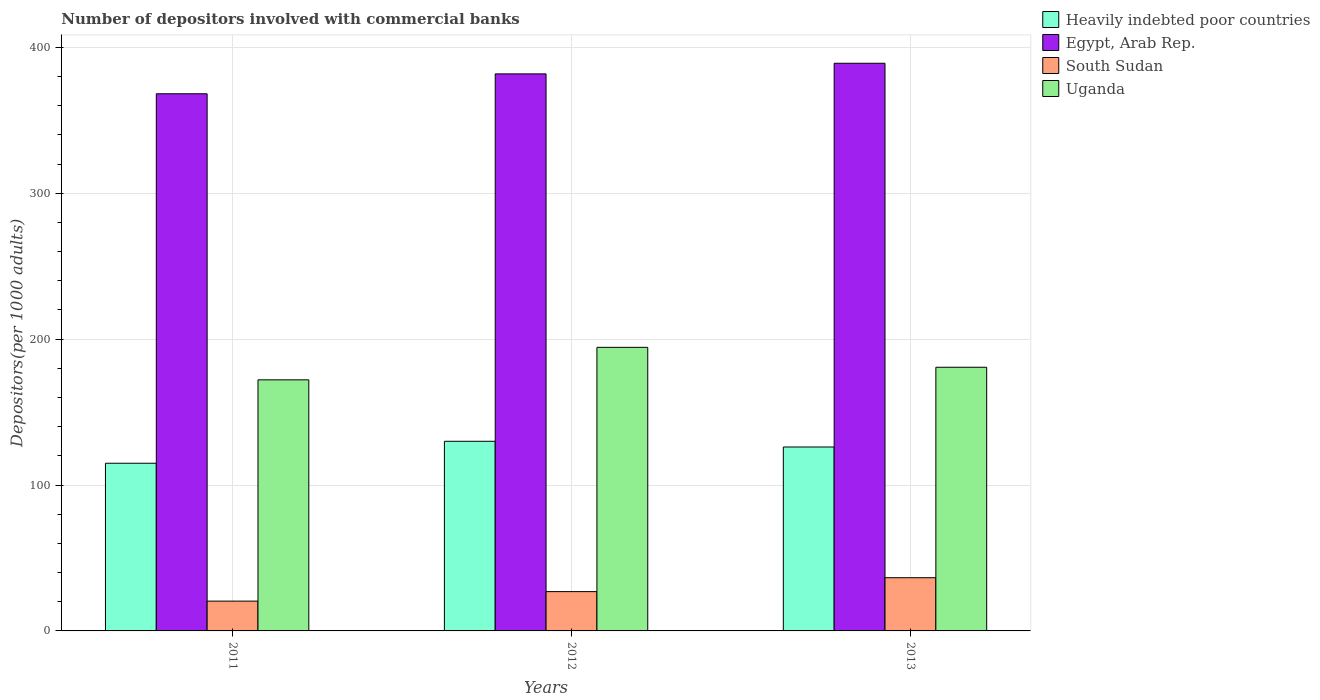How many different coloured bars are there?
Give a very brief answer. 4. Are the number of bars on each tick of the X-axis equal?
Ensure brevity in your answer.  Yes. What is the number of depositors involved with commercial banks in South Sudan in 2011?
Ensure brevity in your answer.  20.42. Across all years, what is the maximum number of depositors involved with commercial banks in Egypt, Arab Rep.?
Your answer should be compact. 389.11. Across all years, what is the minimum number of depositors involved with commercial banks in Heavily indebted poor countries?
Ensure brevity in your answer.  114.93. In which year was the number of depositors involved with commercial banks in Heavily indebted poor countries maximum?
Offer a very short reply. 2012. What is the total number of depositors involved with commercial banks in South Sudan in the graph?
Offer a very short reply. 83.84. What is the difference between the number of depositors involved with commercial banks in South Sudan in 2011 and that in 2013?
Offer a terse response. -16.05. What is the difference between the number of depositors involved with commercial banks in Heavily indebted poor countries in 2011 and the number of depositors involved with commercial banks in South Sudan in 2013?
Provide a short and direct response. 78.46. What is the average number of depositors involved with commercial banks in Egypt, Arab Rep. per year?
Make the answer very short. 379.71. In the year 2011, what is the difference between the number of depositors involved with commercial banks in Egypt, Arab Rep. and number of depositors involved with commercial banks in South Sudan?
Offer a terse response. 347.77. What is the ratio of the number of depositors involved with commercial banks in South Sudan in 2012 to that in 2013?
Offer a terse response. 0.74. Is the number of depositors involved with commercial banks in Heavily indebted poor countries in 2011 less than that in 2013?
Make the answer very short. Yes. Is the difference between the number of depositors involved with commercial banks in Egypt, Arab Rep. in 2011 and 2012 greater than the difference between the number of depositors involved with commercial banks in South Sudan in 2011 and 2012?
Make the answer very short. No. What is the difference between the highest and the second highest number of depositors involved with commercial banks in Heavily indebted poor countries?
Offer a terse response. 3.91. What is the difference between the highest and the lowest number of depositors involved with commercial banks in Egypt, Arab Rep.?
Your response must be concise. 20.91. In how many years, is the number of depositors involved with commercial banks in Egypt, Arab Rep. greater than the average number of depositors involved with commercial banks in Egypt, Arab Rep. taken over all years?
Provide a succinct answer. 2. Is the sum of the number of depositors involved with commercial banks in South Sudan in 2012 and 2013 greater than the maximum number of depositors involved with commercial banks in Heavily indebted poor countries across all years?
Ensure brevity in your answer.  No. Is it the case that in every year, the sum of the number of depositors involved with commercial banks in Egypt, Arab Rep. and number of depositors involved with commercial banks in South Sudan is greater than the sum of number of depositors involved with commercial banks in Uganda and number of depositors involved with commercial banks in Heavily indebted poor countries?
Your answer should be compact. Yes. What does the 4th bar from the left in 2011 represents?
Ensure brevity in your answer.  Uganda. What does the 4th bar from the right in 2013 represents?
Your response must be concise. Heavily indebted poor countries. Is it the case that in every year, the sum of the number of depositors involved with commercial banks in Uganda and number of depositors involved with commercial banks in Egypt, Arab Rep. is greater than the number of depositors involved with commercial banks in South Sudan?
Your response must be concise. Yes. How many bars are there?
Keep it short and to the point. 12. How many years are there in the graph?
Your response must be concise. 3. What is the difference between two consecutive major ticks on the Y-axis?
Provide a short and direct response. 100. Does the graph contain any zero values?
Keep it short and to the point. No. What is the title of the graph?
Ensure brevity in your answer.  Number of depositors involved with commercial banks. Does "Denmark" appear as one of the legend labels in the graph?
Offer a terse response. No. What is the label or title of the Y-axis?
Keep it short and to the point. Depositors(per 1000 adults). What is the Depositors(per 1000 adults) of Heavily indebted poor countries in 2011?
Ensure brevity in your answer.  114.93. What is the Depositors(per 1000 adults) in Egypt, Arab Rep. in 2011?
Your answer should be compact. 368.19. What is the Depositors(per 1000 adults) in South Sudan in 2011?
Make the answer very short. 20.42. What is the Depositors(per 1000 adults) in Uganda in 2011?
Keep it short and to the point. 172.11. What is the Depositors(per 1000 adults) of Heavily indebted poor countries in 2012?
Make the answer very short. 129.98. What is the Depositors(per 1000 adults) in Egypt, Arab Rep. in 2012?
Ensure brevity in your answer.  381.83. What is the Depositors(per 1000 adults) in South Sudan in 2012?
Make the answer very short. 26.94. What is the Depositors(per 1000 adults) in Uganda in 2012?
Give a very brief answer. 194.39. What is the Depositors(per 1000 adults) in Heavily indebted poor countries in 2013?
Your answer should be compact. 126.07. What is the Depositors(per 1000 adults) in Egypt, Arab Rep. in 2013?
Provide a short and direct response. 389.11. What is the Depositors(per 1000 adults) in South Sudan in 2013?
Give a very brief answer. 36.47. What is the Depositors(per 1000 adults) of Uganda in 2013?
Offer a terse response. 180.73. Across all years, what is the maximum Depositors(per 1000 adults) of Heavily indebted poor countries?
Provide a succinct answer. 129.98. Across all years, what is the maximum Depositors(per 1000 adults) in Egypt, Arab Rep.?
Your answer should be very brief. 389.11. Across all years, what is the maximum Depositors(per 1000 adults) in South Sudan?
Offer a very short reply. 36.47. Across all years, what is the maximum Depositors(per 1000 adults) of Uganda?
Make the answer very short. 194.39. Across all years, what is the minimum Depositors(per 1000 adults) in Heavily indebted poor countries?
Make the answer very short. 114.93. Across all years, what is the minimum Depositors(per 1000 adults) in Egypt, Arab Rep.?
Your answer should be compact. 368.19. Across all years, what is the minimum Depositors(per 1000 adults) in South Sudan?
Your answer should be compact. 20.42. Across all years, what is the minimum Depositors(per 1000 adults) of Uganda?
Your answer should be compact. 172.11. What is the total Depositors(per 1000 adults) in Heavily indebted poor countries in the graph?
Your answer should be very brief. 370.99. What is the total Depositors(per 1000 adults) of Egypt, Arab Rep. in the graph?
Keep it short and to the point. 1139.13. What is the total Depositors(per 1000 adults) of South Sudan in the graph?
Offer a very short reply. 83.84. What is the total Depositors(per 1000 adults) of Uganda in the graph?
Make the answer very short. 547.22. What is the difference between the Depositors(per 1000 adults) in Heavily indebted poor countries in 2011 and that in 2012?
Offer a very short reply. -15.05. What is the difference between the Depositors(per 1000 adults) of Egypt, Arab Rep. in 2011 and that in 2012?
Your answer should be very brief. -13.63. What is the difference between the Depositors(per 1000 adults) of South Sudan in 2011 and that in 2012?
Make the answer very short. -6.51. What is the difference between the Depositors(per 1000 adults) of Uganda in 2011 and that in 2012?
Your answer should be compact. -22.28. What is the difference between the Depositors(per 1000 adults) in Heavily indebted poor countries in 2011 and that in 2013?
Provide a short and direct response. -11.14. What is the difference between the Depositors(per 1000 adults) of Egypt, Arab Rep. in 2011 and that in 2013?
Provide a succinct answer. -20.91. What is the difference between the Depositors(per 1000 adults) in South Sudan in 2011 and that in 2013?
Ensure brevity in your answer.  -16.05. What is the difference between the Depositors(per 1000 adults) of Uganda in 2011 and that in 2013?
Your answer should be compact. -8.62. What is the difference between the Depositors(per 1000 adults) of Heavily indebted poor countries in 2012 and that in 2013?
Provide a succinct answer. 3.91. What is the difference between the Depositors(per 1000 adults) in Egypt, Arab Rep. in 2012 and that in 2013?
Your answer should be very brief. -7.28. What is the difference between the Depositors(per 1000 adults) in South Sudan in 2012 and that in 2013?
Your response must be concise. -9.54. What is the difference between the Depositors(per 1000 adults) of Uganda in 2012 and that in 2013?
Provide a short and direct response. 13.66. What is the difference between the Depositors(per 1000 adults) of Heavily indebted poor countries in 2011 and the Depositors(per 1000 adults) of Egypt, Arab Rep. in 2012?
Your response must be concise. -266.89. What is the difference between the Depositors(per 1000 adults) in Heavily indebted poor countries in 2011 and the Depositors(per 1000 adults) in South Sudan in 2012?
Your answer should be very brief. 88. What is the difference between the Depositors(per 1000 adults) of Heavily indebted poor countries in 2011 and the Depositors(per 1000 adults) of Uganda in 2012?
Provide a short and direct response. -79.45. What is the difference between the Depositors(per 1000 adults) of Egypt, Arab Rep. in 2011 and the Depositors(per 1000 adults) of South Sudan in 2012?
Provide a short and direct response. 341.25. What is the difference between the Depositors(per 1000 adults) of Egypt, Arab Rep. in 2011 and the Depositors(per 1000 adults) of Uganda in 2012?
Your response must be concise. 173.81. What is the difference between the Depositors(per 1000 adults) of South Sudan in 2011 and the Depositors(per 1000 adults) of Uganda in 2012?
Offer a terse response. -173.96. What is the difference between the Depositors(per 1000 adults) of Heavily indebted poor countries in 2011 and the Depositors(per 1000 adults) of Egypt, Arab Rep. in 2013?
Make the answer very short. -274.17. What is the difference between the Depositors(per 1000 adults) in Heavily indebted poor countries in 2011 and the Depositors(per 1000 adults) in South Sudan in 2013?
Ensure brevity in your answer.  78.46. What is the difference between the Depositors(per 1000 adults) in Heavily indebted poor countries in 2011 and the Depositors(per 1000 adults) in Uganda in 2013?
Your response must be concise. -65.79. What is the difference between the Depositors(per 1000 adults) in Egypt, Arab Rep. in 2011 and the Depositors(per 1000 adults) in South Sudan in 2013?
Provide a short and direct response. 331.72. What is the difference between the Depositors(per 1000 adults) in Egypt, Arab Rep. in 2011 and the Depositors(per 1000 adults) in Uganda in 2013?
Ensure brevity in your answer.  187.47. What is the difference between the Depositors(per 1000 adults) of South Sudan in 2011 and the Depositors(per 1000 adults) of Uganda in 2013?
Your answer should be very brief. -160.3. What is the difference between the Depositors(per 1000 adults) in Heavily indebted poor countries in 2012 and the Depositors(per 1000 adults) in Egypt, Arab Rep. in 2013?
Give a very brief answer. -259.12. What is the difference between the Depositors(per 1000 adults) of Heavily indebted poor countries in 2012 and the Depositors(per 1000 adults) of South Sudan in 2013?
Offer a very short reply. 93.51. What is the difference between the Depositors(per 1000 adults) of Heavily indebted poor countries in 2012 and the Depositors(per 1000 adults) of Uganda in 2013?
Provide a short and direct response. -50.75. What is the difference between the Depositors(per 1000 adults) in Egypt, Arab Rep. in 2012 and the Depositors(per 1000 adults) in South Sudan in 2013?
Provide a short and direct response. 345.35. What is the difference between the Depositors(per 1000 adults) in Egypt, Arab Rep. in 2012 and the Depositors(per 1000 adults) in Uganda in 2013?
Offer a very short reply. 201.1. What is the difference between the Depositors(per 1000 adults) of South Sudan in 2012 and the Depositors(per 1000 adults) of Uganda in 2013?
Your response must be concise. -153.79. What is the average Depositors(per 1000 adults) in Heavily indebted poor countries per year?
Your answer should be very brief. 123.66. What is the average Depositors(per 1000 adults) in Egypt, Arab Rep. per year?
Provide a succinct answer. 379.71. What is the average Depositors(per 1000 adults) in South Sudan per year?
Ensure brevity in your answer.  27.95. What is the average Depositors(per 1000 adults) of Uganda per year?
Keep it short and to the point. 182.41. In the year 2011, what is the difference between the Depositors(per 1000 adults) of Heavily indebted poor countries and Depositors(per 1000 adults) of Egypt, Arab Rep.?
Make the answer very short. -253.26. In the year 2011, what is the difference between the Depositors(per 1000 adults) in Heavily indebted poor countries and Depositors(per 1000 adults) in South Sudan?
Offer a very short reply. 94.51. In the year 2011, what is the difference between the Depositors(per 1000 adults) in Heavily indebted poor countries and Depositors(per 1000 adults) in Uganda?
Offer a very short reply. -57.17. In the year 2011, what is the difference between the Depositors(per 1000 adults) of Egypt, Arab Rep. and Depositors(per 1000 adults) of South Sudan?
Make the answer very short. 347.77. In the year 2011, what is the difference between the Depositors(per 1000 adults) in Egypt, Arab Rep. and Depositors(per 1000 adults) in Uganda?
Keep it short and to the point. 196.09. In the year 2011, what is the difference between the Depositors(per 1000 adults) in South Sudan and Depositors(per 1000 adults) in Uganda?
Offer a terse response. -151.68. In the year 2012, what is the difference between the Depositors(per 1000 adults) in Heavily indebted poor countries and Depositors(per 1000 adults) in Egypt, Arab Rep.?
Keep it short and to the point. -251.85. In the year 2012, what is the difference between the Depositors(per 1000 adults) in Heavily indebted poor countries and Depositors(per 1000 adults) in South Sudan?
Give a very brief answer. 103.04. In the year 2012, what is the difference between the Depositors(per 1000 adults) in Heavily indebted poor countries and Depositors(per 1000 adults) in Uganda?
Your answer should be very brief. -64.41. In the year 2012, what is the difference between the Depositors(per 1000 adults) of Egypt, Arab Rep. and Depositors(per 1000 adults) of South Sudan?
Your answer should be compact. 354.89. In the year 2012, what is the difference between the Depositors(per 1000 adults) in Egypt, Arab Rep. and Depositors(per 1000 adults) in Uganda?
Your response must be concise. 187.44. In the year 2012, what is the difference between the Depositors(per 1000 adults) of South Sudan and Depositors(per 1000 adults) of Uganda?
Give a very brief answer. -167.45. In the year 2013, what is the difference between the Depositors(per 1000 adults) of Heavily indebted poor countries and Depositors(per 1000 adults) of Egypt, Arab Rep.?
Your response must be concise. -263.03. In the year 2013, what is the difference between the Depositors(per 1000 adults) of Heavily indebted poor countries and Depositors(per 1000 adults) of South Sudan?
Ensure brevity in your answer.  89.6. In the year 2013, what is the difference between the Depositors(per 1000 adults) of Heavily indebted poor countries and Depositors(per 1000 adults) of Uganda?
Make the answer very short. -54.66. In the year 2013, what is the difference between the Depositors(per 1000 adults) in Egypt, Arab Rep. and Depositors(per 1000 adults) in South Sudan?
Give a very brief answer. 352.63. In the year 2013, what is the difference between the Depositors(per 1000 adults) in Egypt, Arab Rep. and Depositors(per 1000 adults) in Uganda?
Make the answer very short. 208.38. In the year 2013, what is the difference between the Depositors(per 1000 adults) of South Sudan and Depositors(per 1000 adults) of Uganda?
Keep it short and to the point. -144.25. What is the ratio of the Depositors(per 1000 adults) in Heavily indebted poor countries in 2011 to that in 2012?
Provide a short and direct response. 0.88. What is the ratio of the Depositors(per 1000 adults) in South Sudan in 2011 to that in 2012?
Provide a succinct answer. 0.76. What is the ratio of the Depositors(per 1000 adults) in Uganda in 2011 to that in 2012?
Keep it short and to the point. 0.89. What is the ratio of the Depositors(per 1000 adults) in Heavily indebted poor countries in 2011 to that in 2013?
Your answer should be compact. 0.91. What is the ratio of the Depositors(per 1000 adults) in Egypt, Arab Rep. in 2011 to that in 2013?
Your answer should be very brief. 0.95. What is the ratio of the Depositors(per 1000 adults) of South Sudan in 2011 to that in 2013?
Your answer should be compact. 0.56. What is the ratio of the Depositors(per 1000 adults) in Uganda in 2011 to that in 2013?
Offer a terse response. 0.95. What is the ratio of the Depositors(per 1000 adults) of Heavily indebted poor countries in 2012 to that in 2013?
Offer a very short reply. 1.03. What is the ratio of the Depositors(per 1000 adults) of Egypt, Arab Rep. in 2012 to that in 2013?
Offer a terse response. 0.98. What is the ratio of the Depositors(per 1000 adults) of South Sudan in 2012 to that in 2013?
Offer a terse response. 0.74. What is the ratio of the Depositors(per 1000 adults) in Uganda in 2012 to that in 2013?
Ensure brevity in your answer.  1.08. What is the difference between the highest and the second highest Depositors(per 1000 adults) in Heavily indebted poor countries?
Your answer should be very brief. 3.91. What is the difference between the highest and the second highest Depositors(per 1000 adults) of Egypt, Arab Rep.?
Give a very brief answer. 7.28. What is the difference between the highest and the second highest Depositors(per 1000 adults) in South Sudan?
Keep it short and to the point. 9.54. What is the difference between the highest and the second highest Depositors(per 1000 adults) in Uganda?
Keep it short and to the point. 13.66. What is the difference between the highest and the lowest Depositors(per 1000 adults) of Heavily indebted poor countries?
Keep it short and to the point. 15.05. What is the difference between the highest and the lowest Depositors(per 1000 adults) of Egypt, Arab Rep.?
Provide a short and direct response. 20.91. What is the difference between the highest and the lowest Depositors(per 1000 adults) of South Sudan?
Offer a terse response. 16.05. What is the difference between the highest and the lowest Depositors(per 1000 adults) in Uganda?
Offer a very short reply. 22.28. 